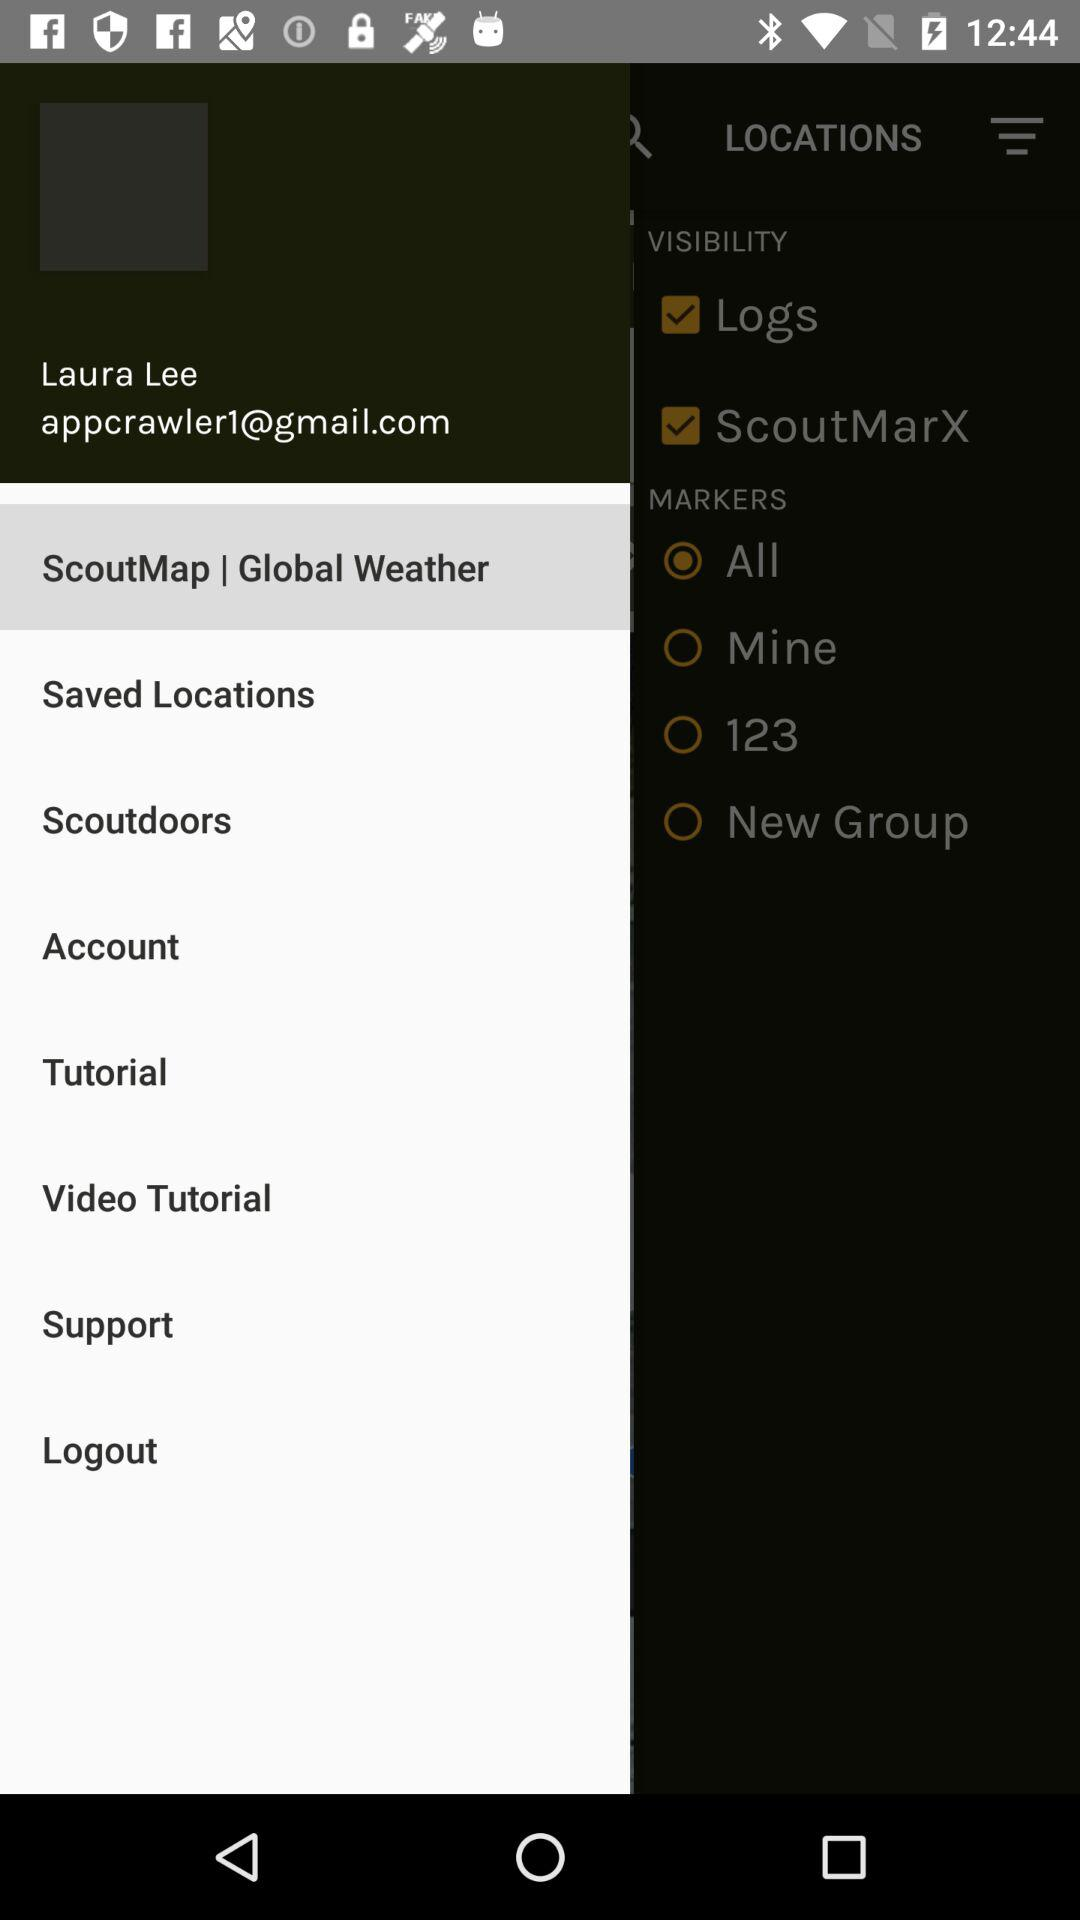Which option was selected? The selected option was "ScoutMap | Global Weather". 